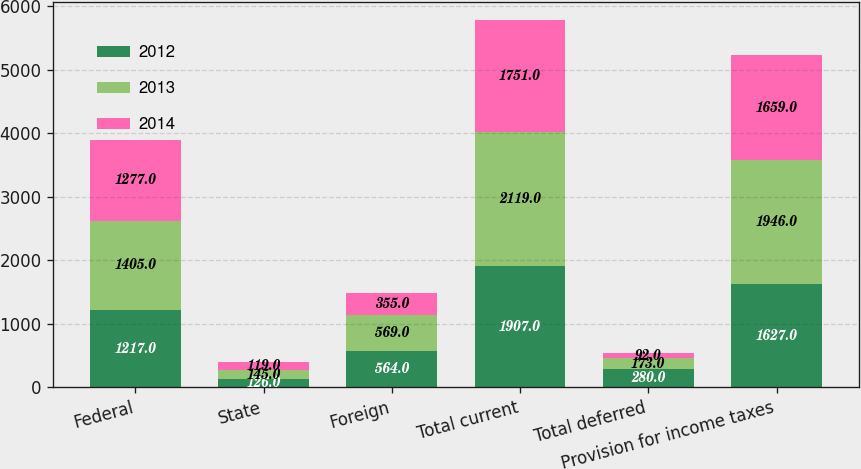Convert chart. <chart><loc_0><loc_0><loc_500><loc_500><stacked_bar_chart><ecel><fcel>Federal<fcel>State<fcel>Foreign<fcel>Total current<fcel>Total deferred<fcel>Provision for income taxes<nl><fcel>2012<fcel>1217<fcel>126<fcel>564<fcel>1907<fcel>280<fcel>1627<nl><fcel>2013<fcel>1405<fcel>145<fcel>569<fcel>2119<fcel>173<fcel>1946<nl><fcel>2014<fcel>1277<fcel>119<fcel>355<fcel>1751<fcel>92<fcel>1659<nl></chart> 